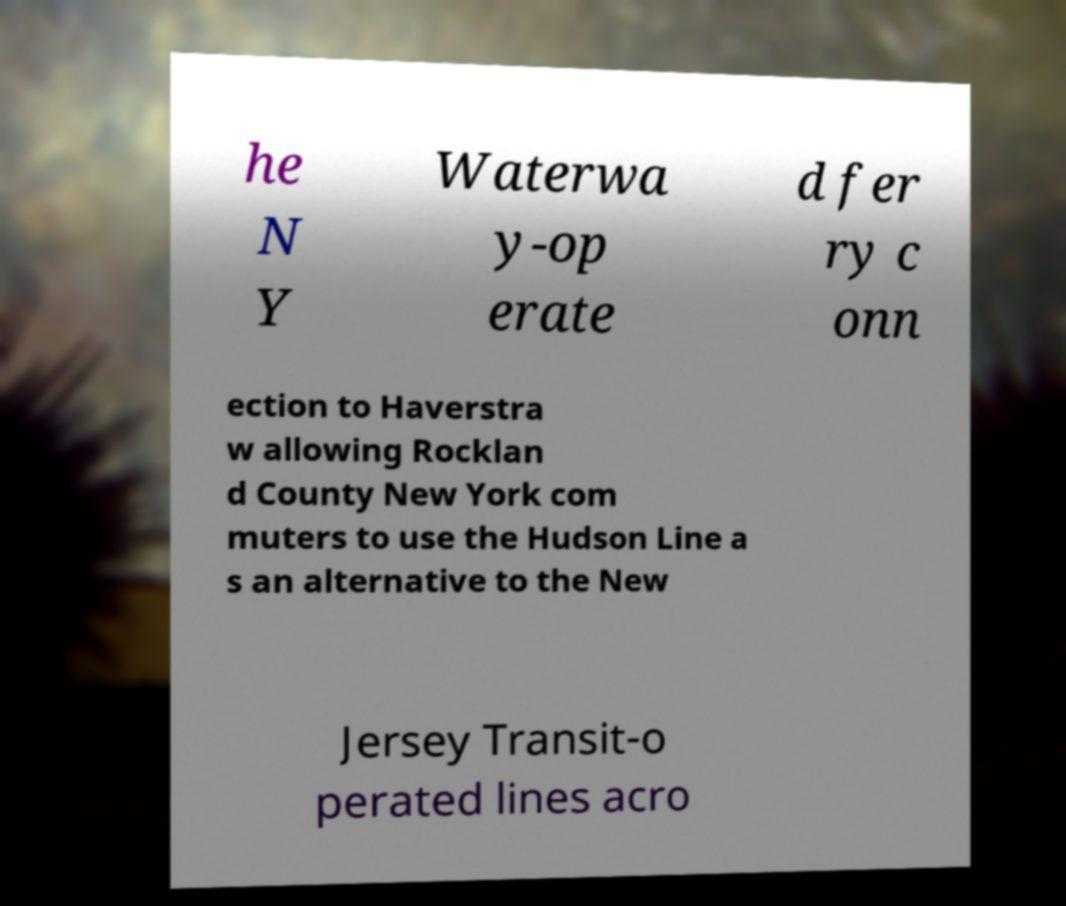What messages or text are displayed in this image? I need them in a readable, typed format. he N Y Waterwa y-op erate d fer ry c onn ection to Haverstra w allowing Rocklan d County New York com muters to use the Hudson Line a s an alternative to the New Jersey Transit-o perated lines acro 